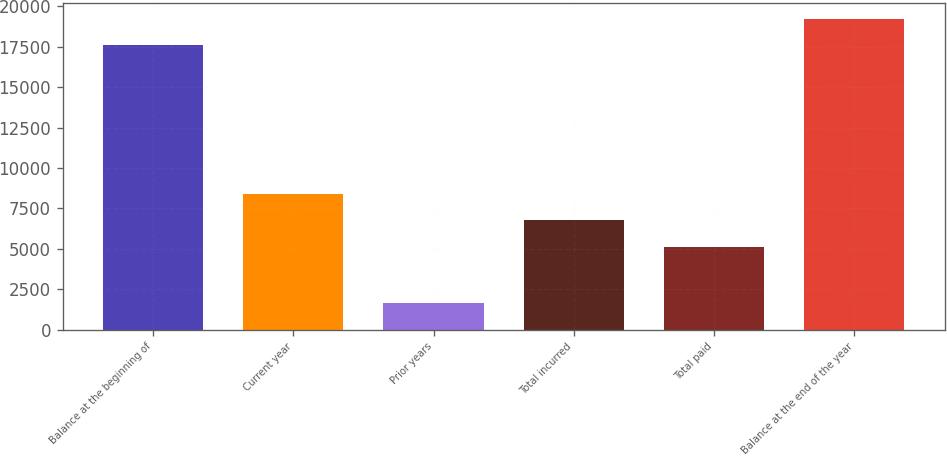Convert chart. <chart><loc_0><loc_0><loc_500><loc_500><bar_chart><fcel>Balance at the beginning of<fcel>Current year<fcel>Prior years<fcel>Total incurred<fcel>Total paid<fcel>Balance at the end of the year<nl><fcel>17602<fcel>8415.4<fcel>1671<fcel>6774.7<fcel>5134<fcel>19242.7<nl></chart> 